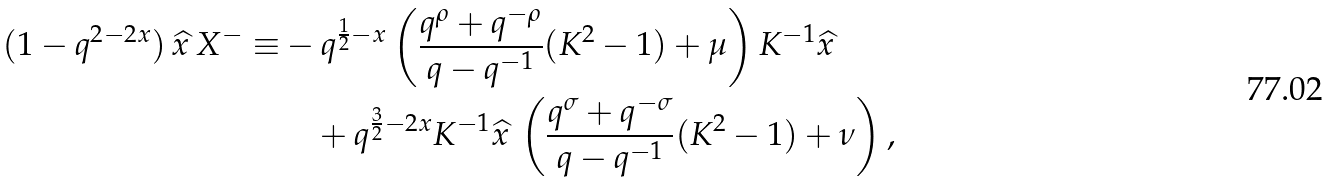<formula> <loc_0><loc_0><loc_500><loc_500>( 1 - q ^ { 2 - 2 x } ) \, \widehat { x } \, X ^ { - } \equiv & - q ^ { \frac { 1 } { 2 } - x } \left ( \frac { q ^ { \rho } + q ^ { - \rho } } { q - q ^ { - 1 } } ( K ^ { 2 } - 1 ) + \mu \right ) K ^ { - 1 } \widehat { x } \\ & \quad + q ^ { \frac { 3 } { 2 } - 2 x } K ^ { - 1 } \widehat { x } \, \left ( \frac { q ^ { \sigma } + q ^ { - \sigma } } { q - q ^ { - 1 } } ( K ^ { 2 } - 1 ) + \nu \right ) ,</formula> 